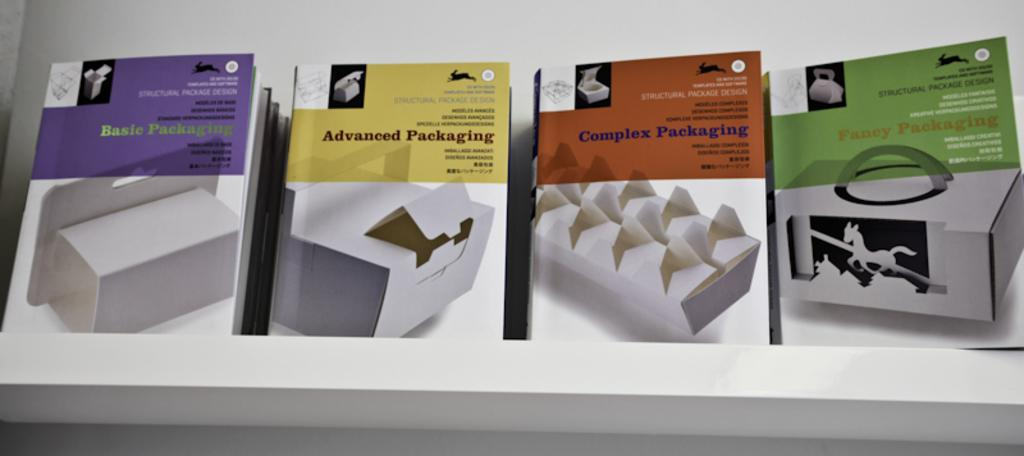<image>
Describe the image concisely. four different packages with one labeled 'adavanced packaging' 